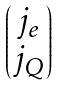Convert formula to latex. <formula><loc_0><loc_0><loc_500><loc_500>\begin{pmatrix} j _ { e } \\ j _ { Q } \end{pmatrix}</formula> 